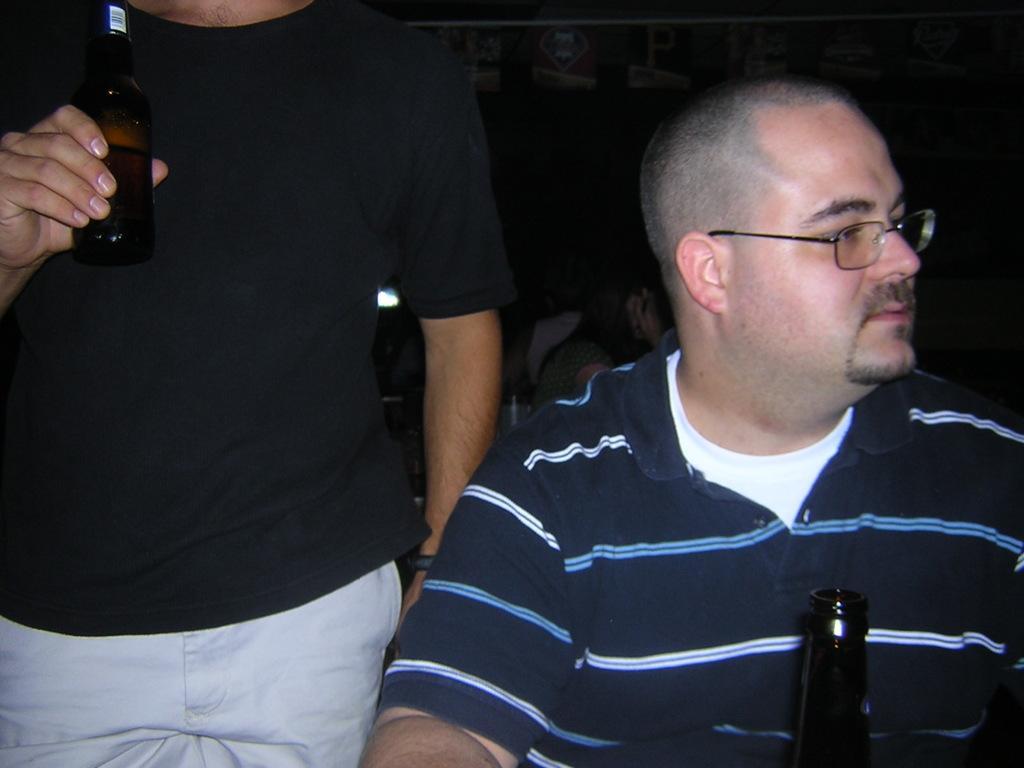In one or two sentences, can you explain what this image depicts? In this picture we can see a man. He has spectacles. And this is the bottle. Here we can see a man who is holding a bottle with his hand. 